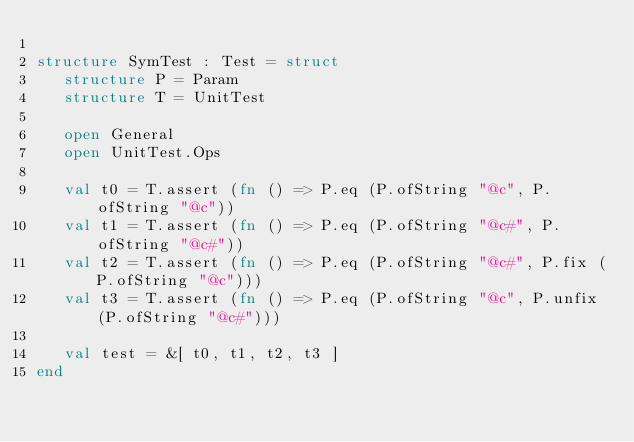<code> <loc_0><loc_0><loc_500><loc_500><_SML_>
structure SymTest : Test = struct
   structure P = Param
   structure T = UnitTest

   open General
   open UnitTest.Ops

   val t0 = T.assert (fn () => P.eq (P.ofString "@c", P.ofString "@c"))
   val t1 = T.assert (fn () => P.eq (P.ofString "@c#", P.ofString "@c#"))
   val t2 = T.assert (fn () => P.eq (P.ofString "@c#", P.fix (P.ofString "@c")))
   val t3 = T.assert (fn () => P.eq (P.ofString "@c", P.unfix (P.ofString "@c#")))

   val test = &[ t0, t1, t2, t3 ]
end
</code> 